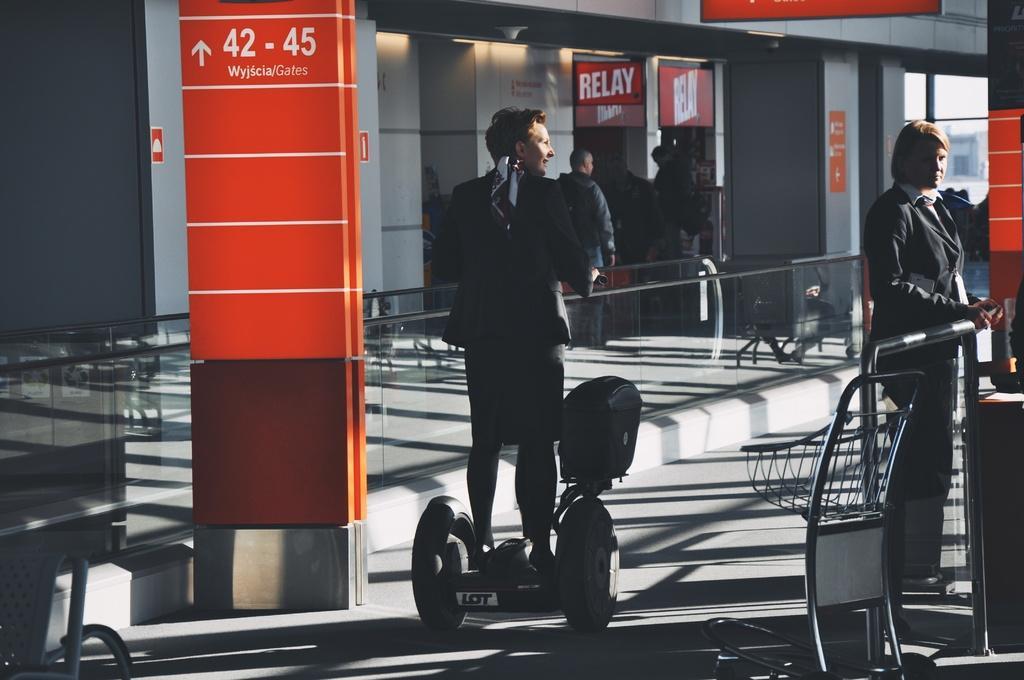Please provide a concise description of this image. In this picture we can see some people and a man standing on a hoverboard, trolley on the floor, railings, posters and some objects and in the background we can see a building. 